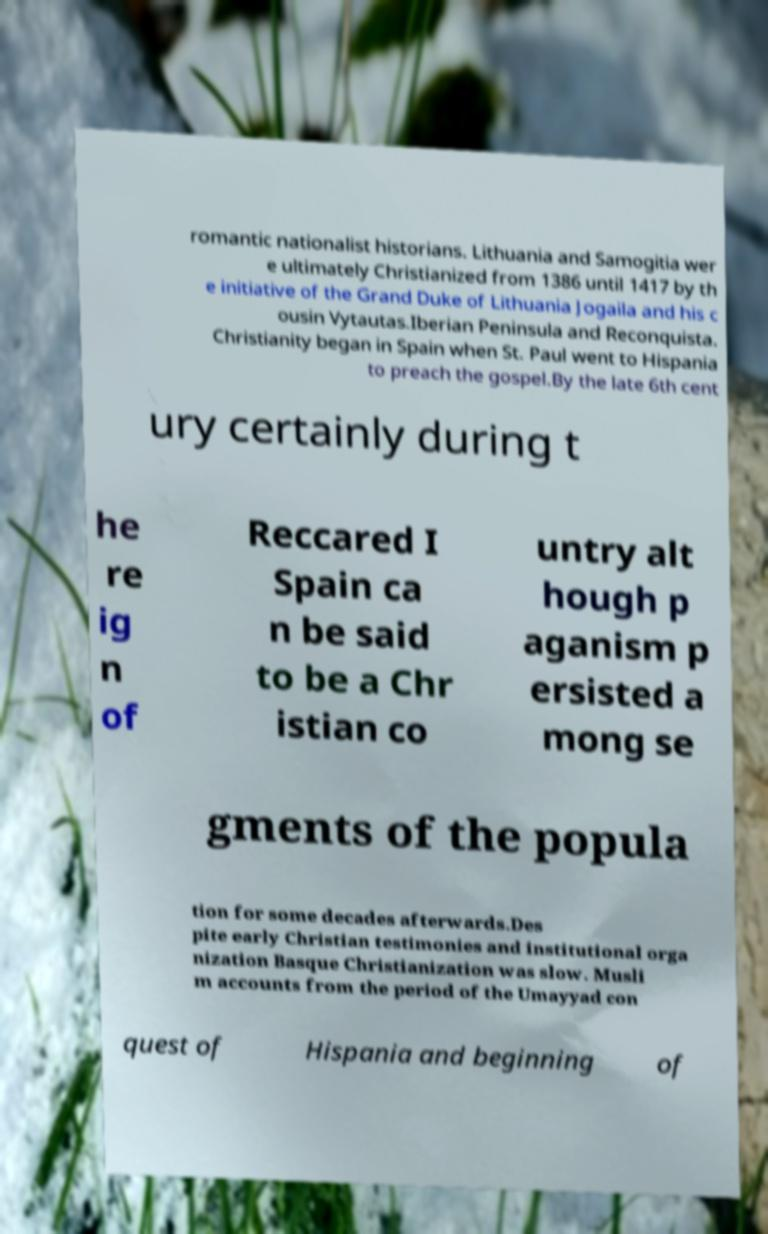Can you accurately transcribe the text from the provided image for me? romantic nationalist historians. Lithuania and Samogitia wer e ultimately Christianized from 1386 until 1417 by th e initiative of the Grand Duke of Lithuania Jogaila and his c ousin Vytautas.Iberian Peninsula and Reconquista. Christianity began in Spain when St. Paul went to Hispania to preach the gospel.By the late 6th cent ury certainly during t he re ig n of Reccared I Spain ca n be said to be a Chr istian co untry alt hough p aganism p ersisted a mong se gments of the popula tion for some decades afterwards.Des pite early Christian testimonies and institutional orga nization Basque Christianization was slow. Musli m accounts from the period of the Umayyad con quest of Hispania and beginning of 